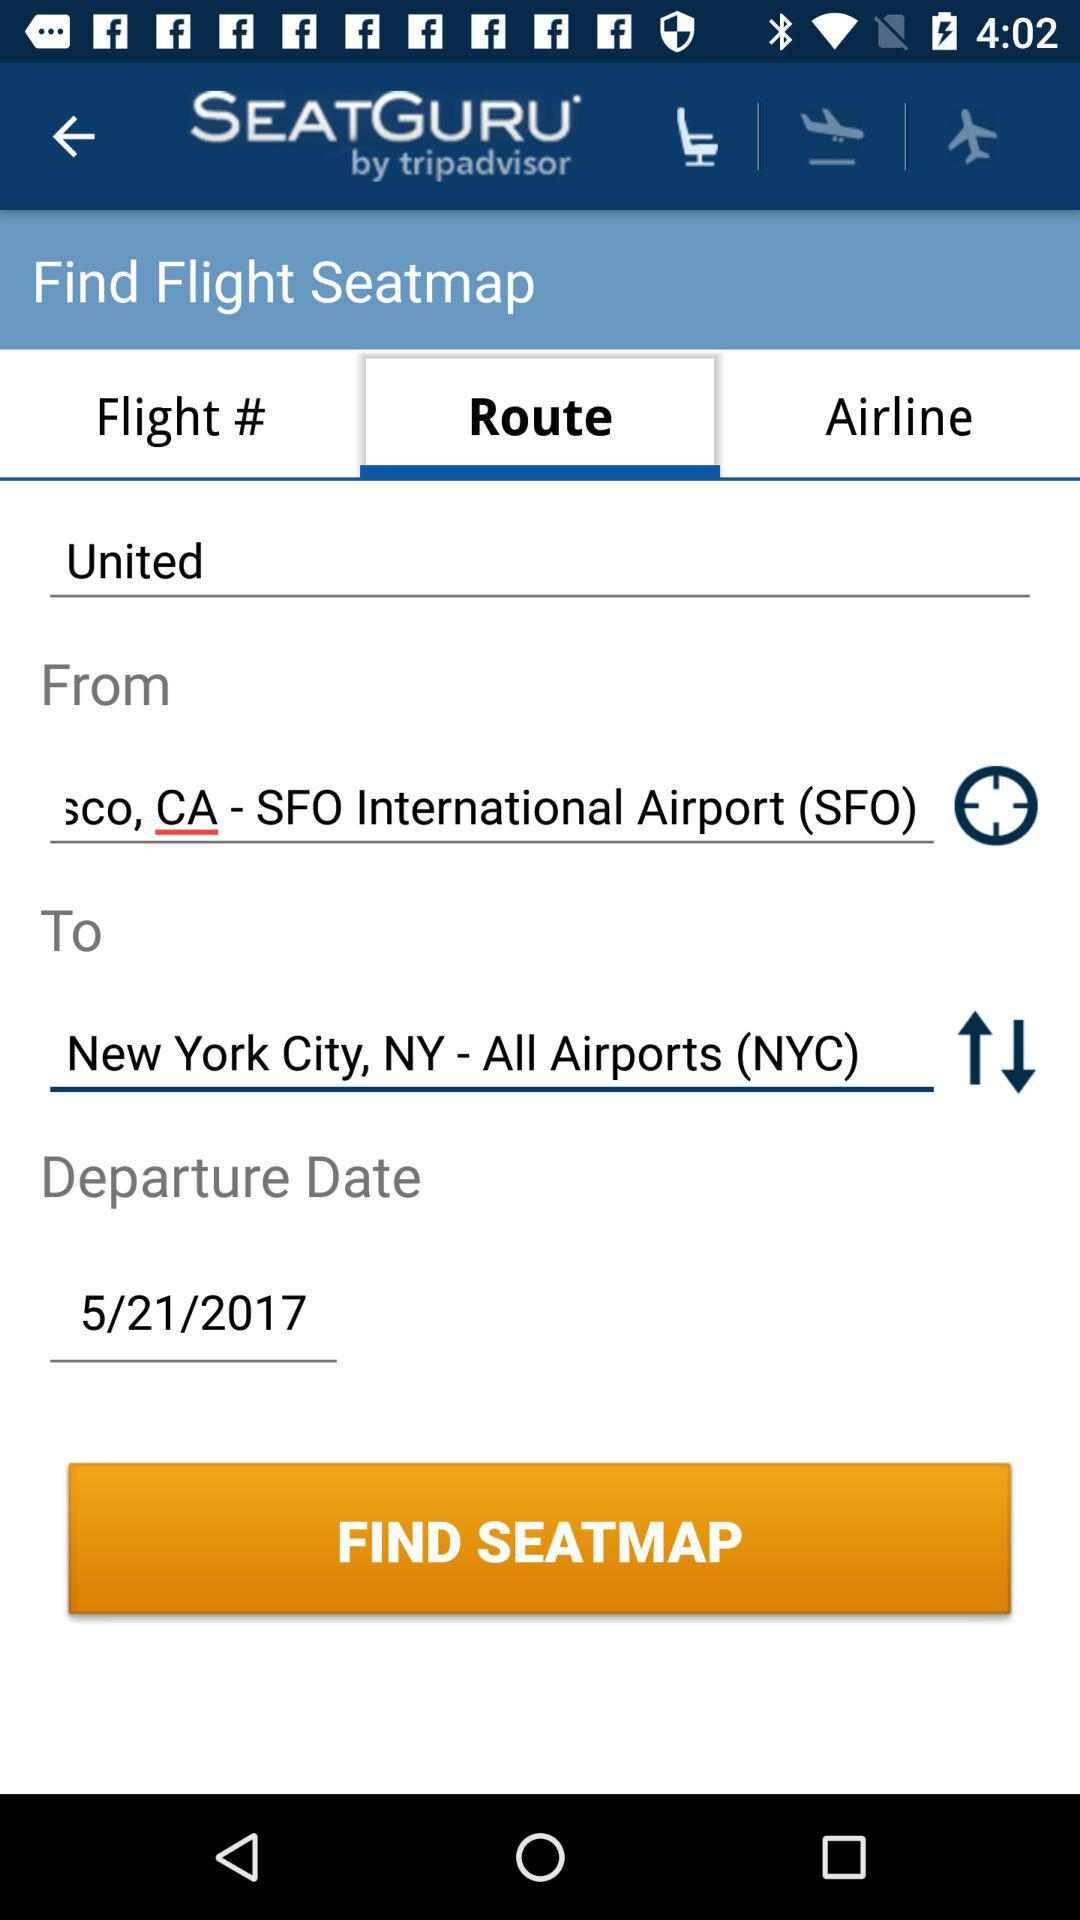What is the departure date? The departure date is May 21, 2017. 